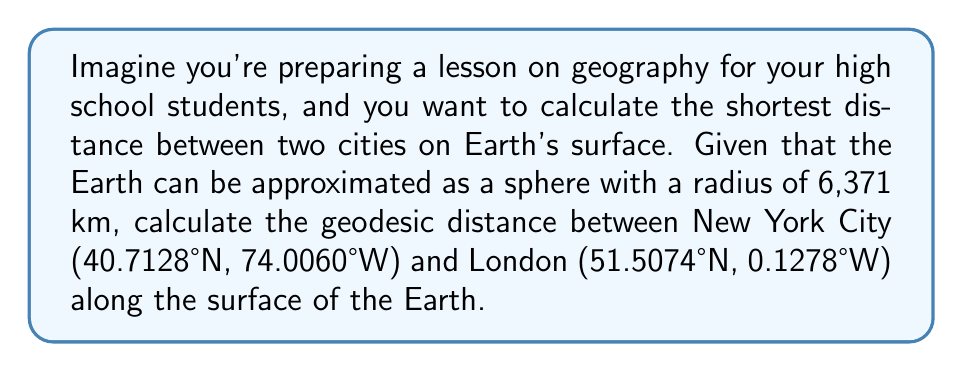Can you solve this math problem? To calculate the geodesic distance between two points on a spherical surface, we use the great circle distance formula. This formula is derived from spherical trigonometry and provides the shortest path between two points on a sphere. Let's break down the process step-by-step:

1. Convert the latitudes and longitudes from degrees to radians:
   $\phi_1 = 40.7128° \times \frac{\pi}{180} = 0.7102$ radians (New York)
   $\lambda_1 = -74.0060° \times \frac{\pi}{180} = -1.2917$ radians (New York)
   $\phi_2 = 51.5074° \times \frac{\pi}{180} = 0.8990$ radians (London)
   $\lambda_2 = -0.1278° \times \frac{\pi}{180} = -0.0022$ radians (London)

2. Calculate the central angle $\Delta\sigma$ using the Haversine formula:
   $$\Delta\sigma = 2 \arcsin\left(\sqrt{\sin^2\left(\frac{\phi_2 - \phi_1}{2}\right) + \cos\phi_1 \cos\phi_2 \sin^2\left(\frac{\lambda_2 - \lambda_1}{2}\right)}\right)$$

3. Substitute the values:
   $$\Delta\sigma = 2 \arcsin\left(\sqrt{\sin^2\left(\frac{0.8990 - 0.7102}{2}\right) + \cos(0.7102) \cos(0.8990) \sin^2\left(\frac{-0.0022 - (-1.2917)}{2}\right)}\right)$$

4. Calculate the result:
   $\Delta\sigma \approx 0.9688$ radians

5. The geodesic distance $d$ is then calculated by multiplying the central angle by the Earth's radius:
   $d = R \times \Delta\sigma$
   where $R = 6,371$ km (Earth's radius)

6. Calculate the final distance:
   $d = 6,371 \times 0.9688 \approx 6,172$ km

This method provides an accurate approximation of the shortest distance between two points on the Earth's surface, assuming a perfectly spherical Earth.
Answer: The geodesic distance between New York City and London is approximately 6,172 km. 